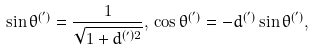Convert formula to latex. <formula><loc_0><loc_0><loc_500><loc_500>\sin \theta ^ { ( ^ { \prime } ) } = \frac { 1 } { \sqrt { 1 + d ^ { ( ^ { \prime } ) 2 } } } , \, \cos \theta ^ { ( ^ { \prime } ) } = - d ^ { ( ^ { \prime } ) } \sin \theta ^ { ( ^ { \prime } ) } ,</formula> 